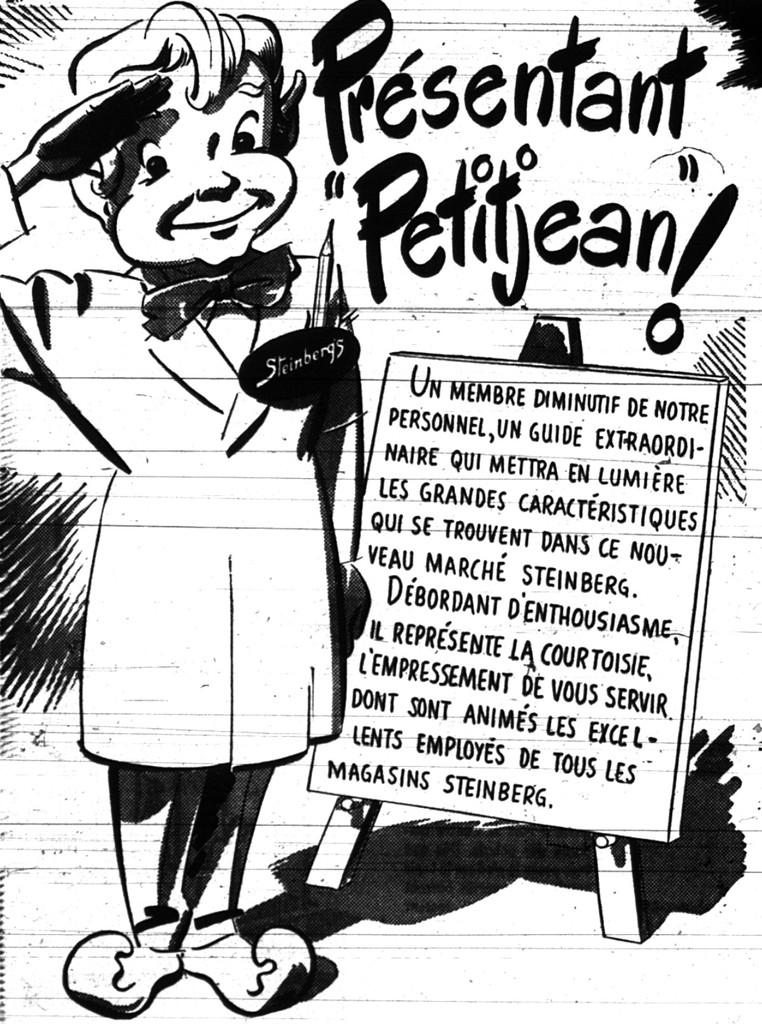What is depicted in the image? There is a sketch of a person in the image. Is there any text present in the image? Yes, there is writing on the image. What is the title of the battle depicted in the image? There is no battle depicted in the image, and therefore no title can be assigned to it. 